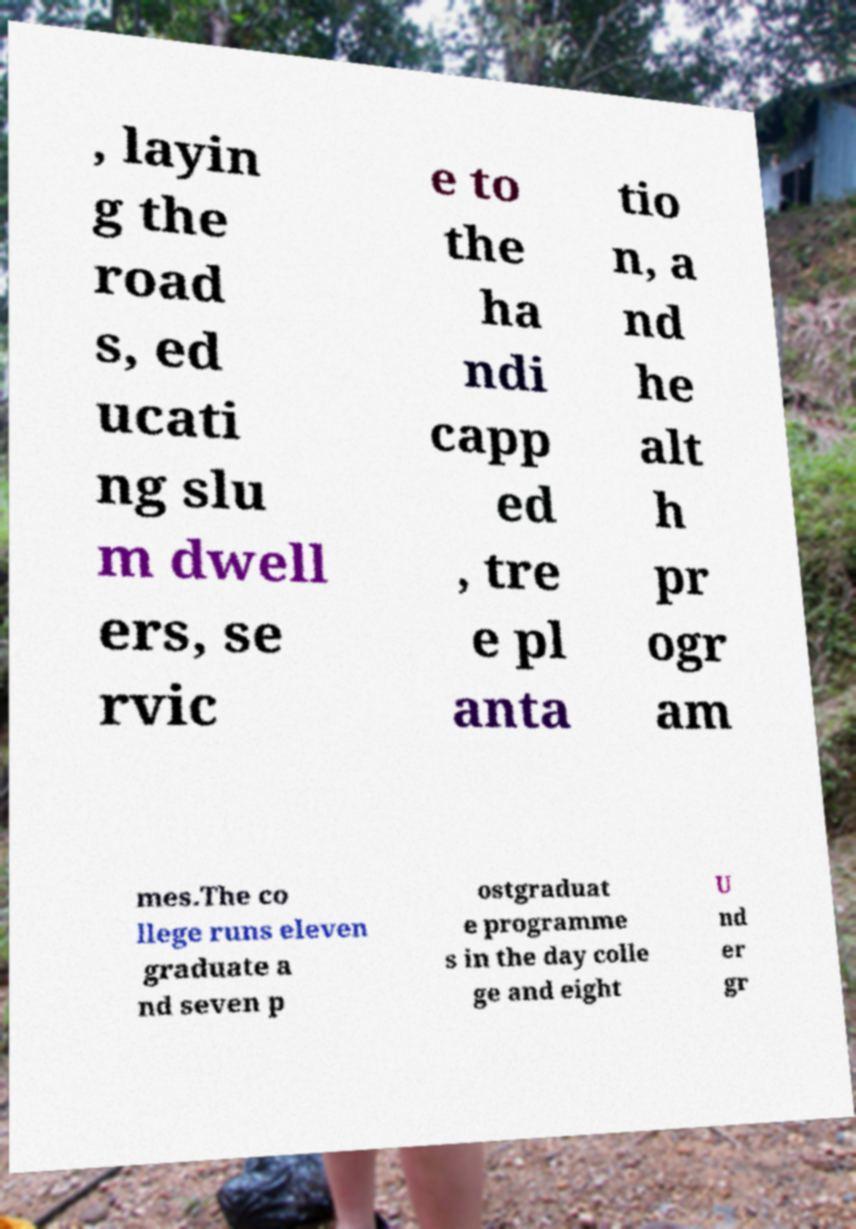Could you extract and type out the text from this image? , layin g the road s, ed ucati ng slu m dwell ers, se rvic e to the ha ndi capp ed , tre e pl anta tio n, a nd he alt h pr ogr am mes.The co llege runs eleven graduate a nd seven p ostgraduat e programme s in the day colle ge and eight U nd er gr 